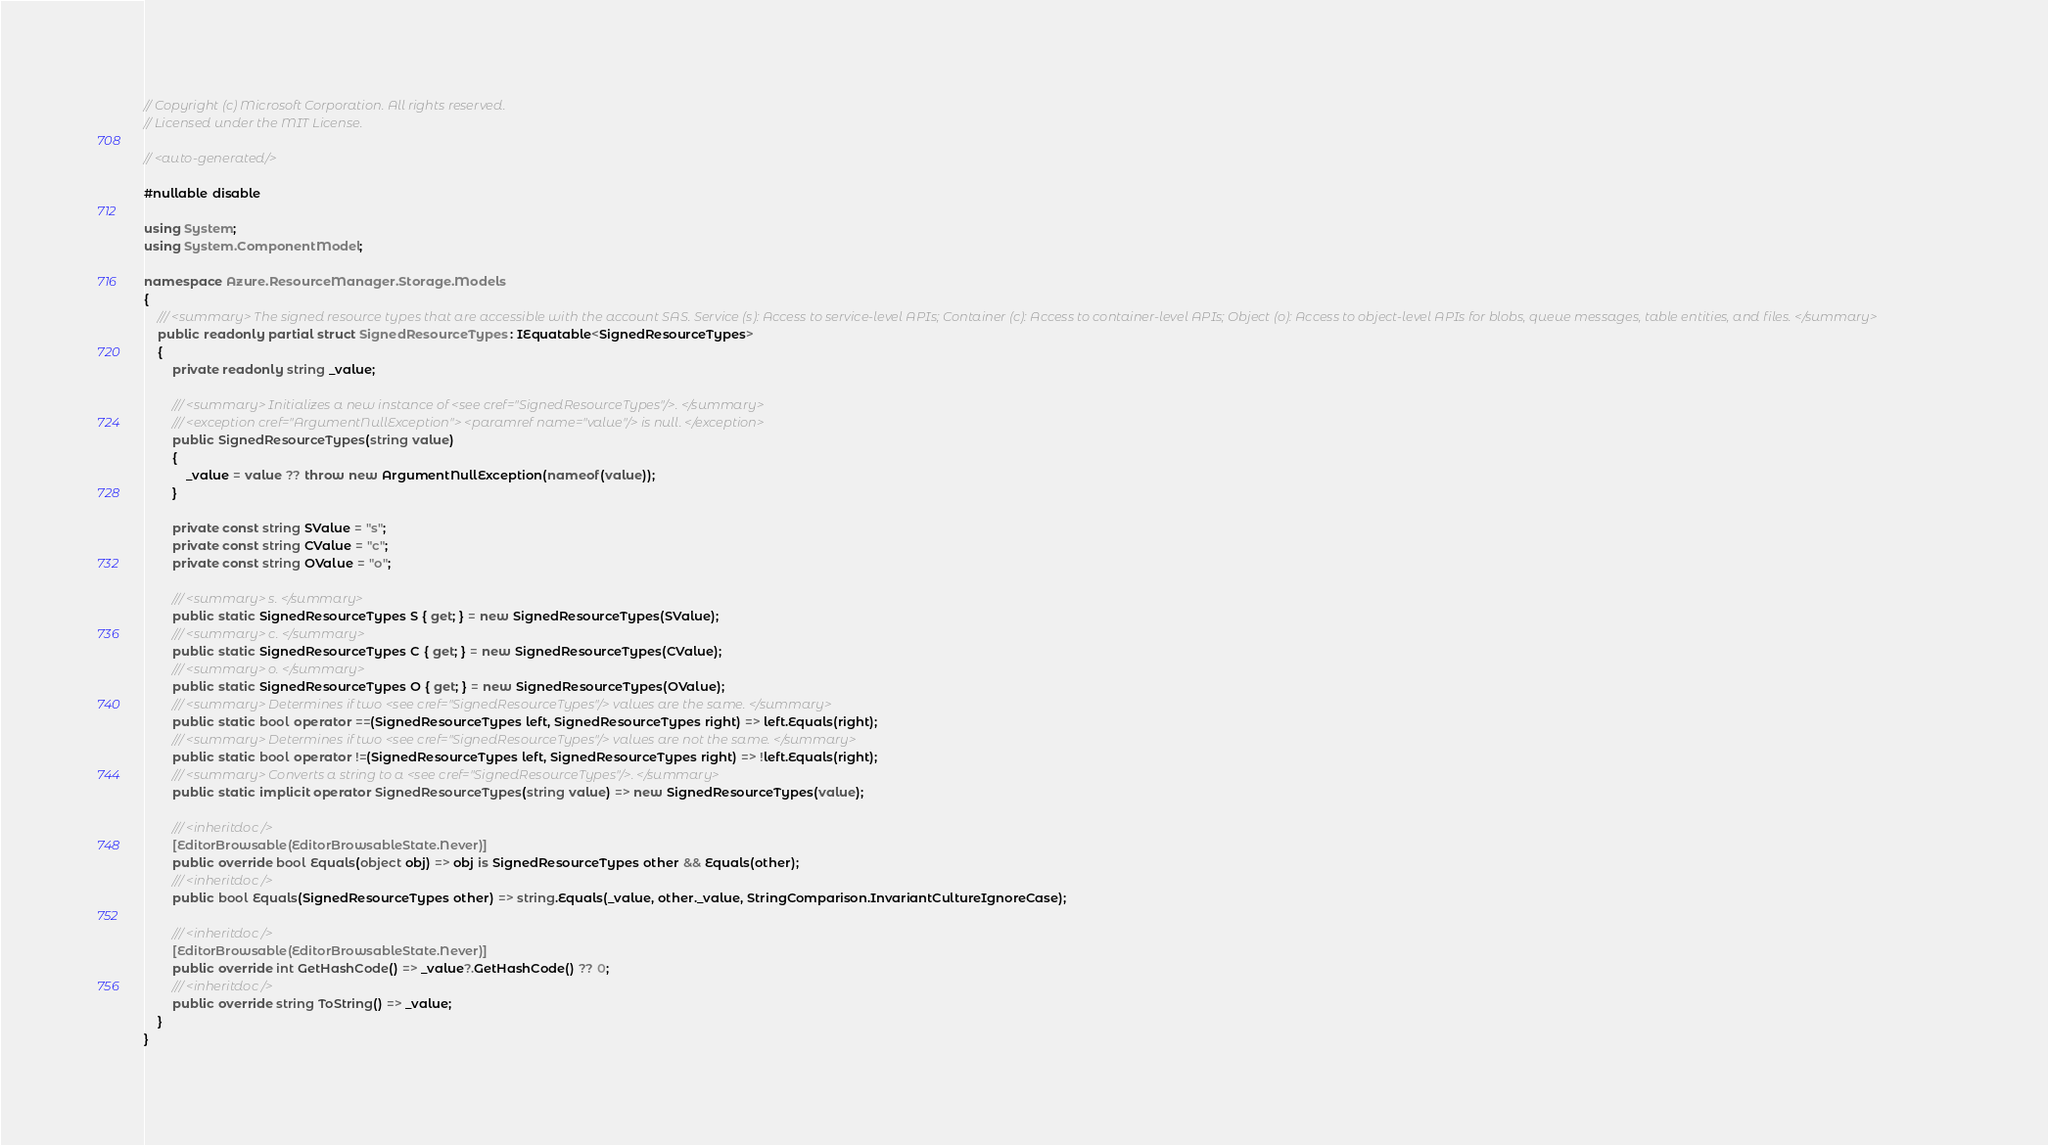Convert code to text. <code><loc_0><loc_0><loc_500><loc_500><_C#_>// Copyright (c) Microsoft Corporation. All rights reserved.
// Licensed under the MIT License.

// <auto-generated/>

#nullable disable

using System;
using System.ComponentModel;

namespace Azure.ResourceManager.Storage.Models
{
    /// <summary> The signed resource types that are accessible with the account SAS. Service (s): Access to service-level APIs; Container (c): Access to container-level APIs; Object (o): Access to object-level APIs for blobs, queue messages, table entities, and files. </summary>
    public readonly partial struct SignedResourceTypes : IEquatable<SignedResourceTypes>
    {
        private readonly string _value;

        /// <summary> Initializes a new instance of <see cref="SignedResourceTypes"/>. </summary>
        /// <exception cref="ArgumentNullException"> <paramref name="value"/> is null. </exception>
        public SignedResourceTypes(string value)
        {
            _value = value ?? throw new ArgumentNullException(nameof(value));
        }

        private const string SValue = "s";
        private const string CValue = "c";
        private const string OValue = "o";

        /// <summary> s. </summary>
        public static SignedResourceTypes S { get; } = new SignedResourceTypes(SValue);
        /// <summary> c. </summary>
        public static SignedResourceTypes C { get; } = new SignedResourceTypes(CValue);
        /// <summary> o. </summary>
        public static SignedResourceTypes O { get; } = new SignedResourceTypes(OValue);
        /// <summary> Determines if two <see cref="SignedResourceTypes"/> values are the same. </summary>
        public static bool operator ==(SignedResourceTypes left, SignedResourceTypes right) => left.Equals(right);
        /// <summary> Determines if two <see cref="SignedResourceTypes"/> values are not the same. </summary>
        public static bool operator !=(SignedResourceTypes left, SignedResourceTypes right) => !left.Equals(right);
        /// <summary> Converts a string to a <see cref="SignedResourceTypes"/>. </summary>
        public static implicit operator SignedResourceTypes(string value) => new SignedResourceTypes(value);

        /// <inheritdoc />
        [EditorBrowsable(EditorBrowsableState.Never)]
        public override bool Equals(object obj) => obj is SignedResourceTypes other && Equals(other);
        /// <inheritdoc />
        public bool Equals(SignedResourceTypes other) => string.Equals(_value, other._value, StringComparison.InvariantCultureIgnoreCase);

        /// <inheritdoc />
        [EditorBrowsable(EditorBrowsableState.Never)]
        public override int GetHashCode() => _value?.GetHashCode() ?? 0;
        /// <inheritdoc />
        public override string ToString() => _value;
    }
}
</code> 